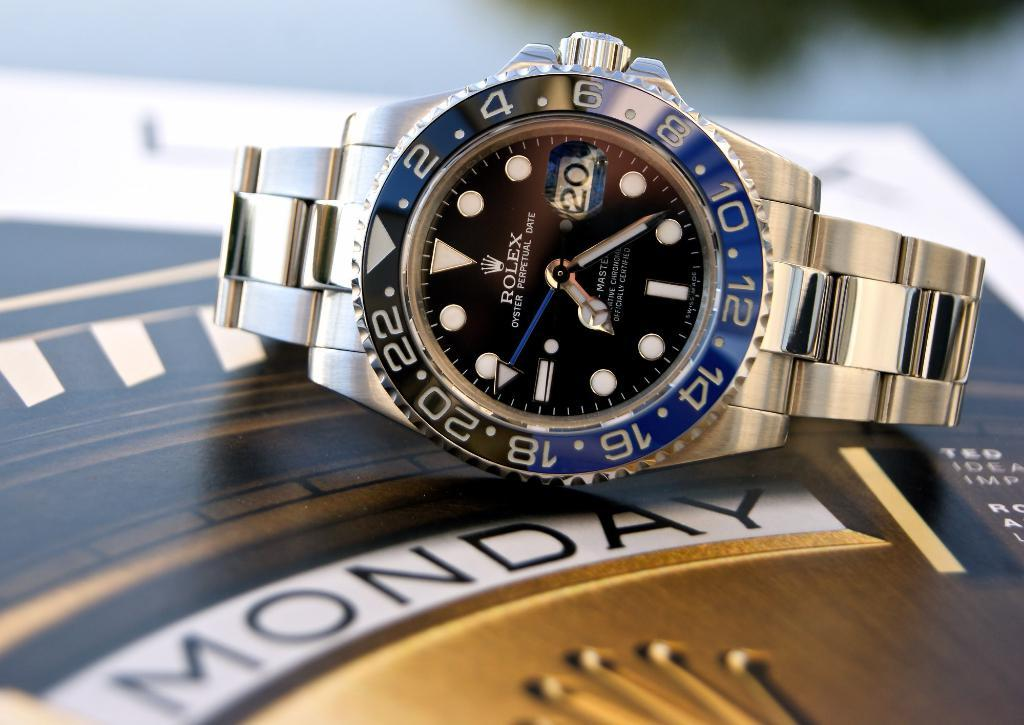<image>
Share a concise interpretation of the image provided. A Rolex watch sits on top of the word Monday. 